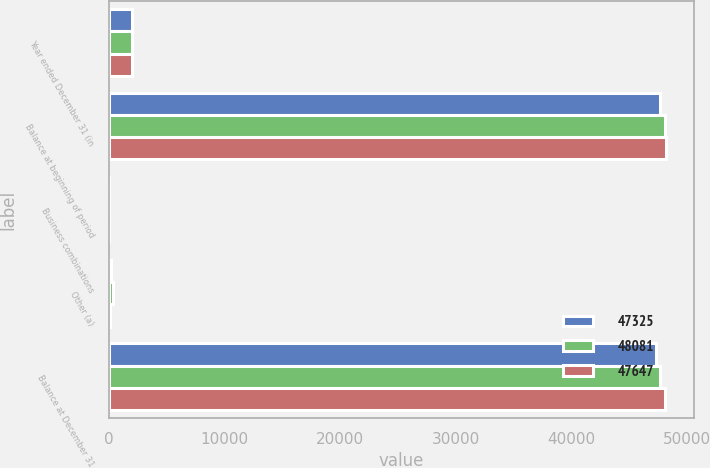<chart> <loc_0><loc_0><loc_500><loc_500><stacked_bar_chart><ecel><fcel>Year ended December 31 (in<fcel>Balance at beginning of period<fcel>Business combinations<fcel>Other (a)<fcel>Balance at December 31<nl><fcel>47325<fcel>2015<fcel>47647<fcel>28<fcel>190<fcel>47325<nl><fcel>48081<fcel>2014<fcel>48081<fcel>43<fcel>397<fcel>47647<nl><fcel>47647<fcel>2013<fcel>48175<fcel>64<fcel>153<fcel>48081<nl></chart> 